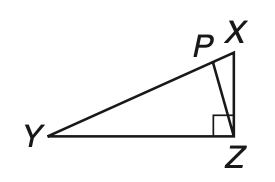Question: Given right triangle X Y Z with hypotenuse X Y, Y P is equal to Y Z. If m \angle P Y Z = 26, find m \angle X Z P.
Choices:
A. 13
B. 26
C. 32
D. 64
Answer with the letter. Answer: A 